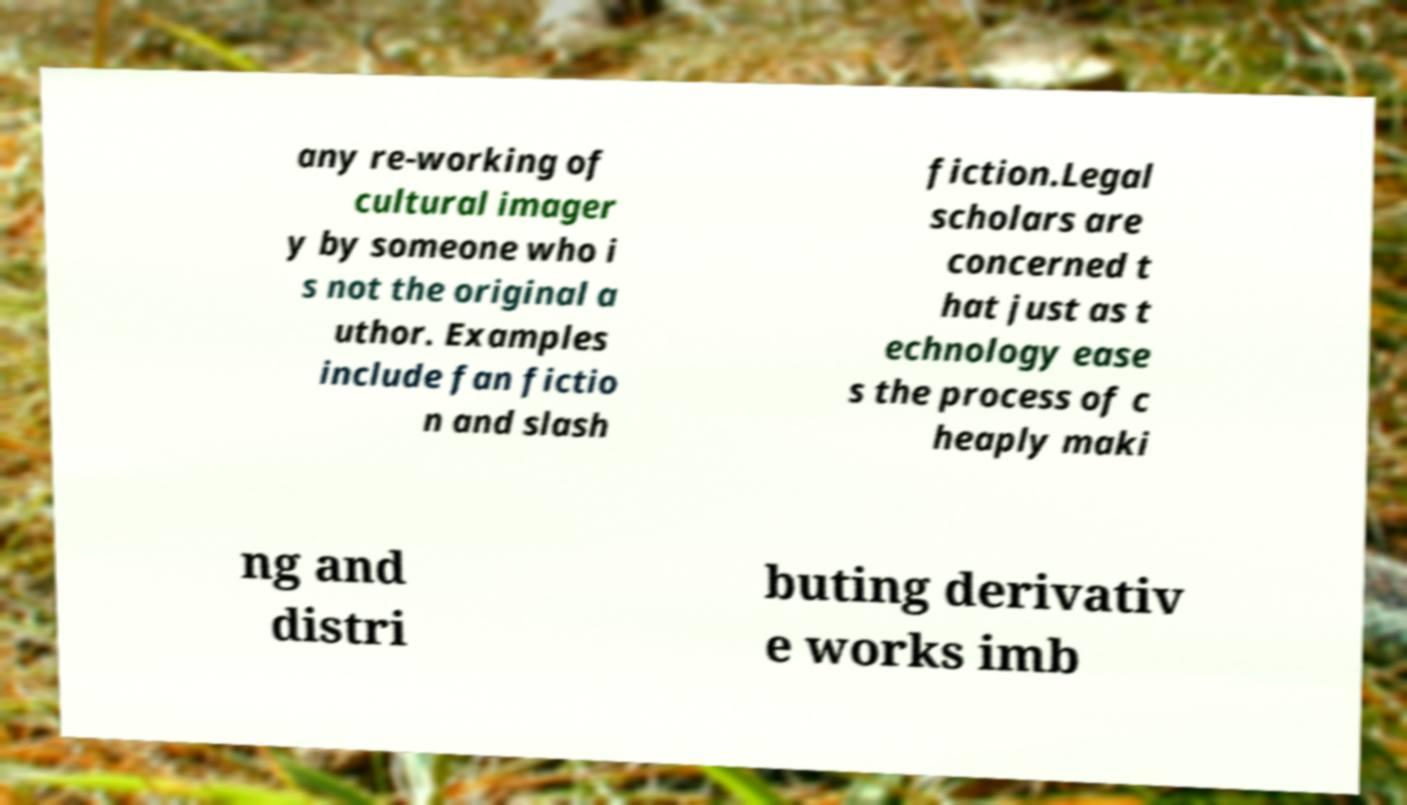Could you extract and type out the text from this image? any re-working of cultural imager y by someone who i s not the original a uthor. Examples include fan fictio n and slash fiction.Legal scholars are concerned t hat just as t echnology ease s the process of c heaply maki ng and distri buting derivativ e works imb 